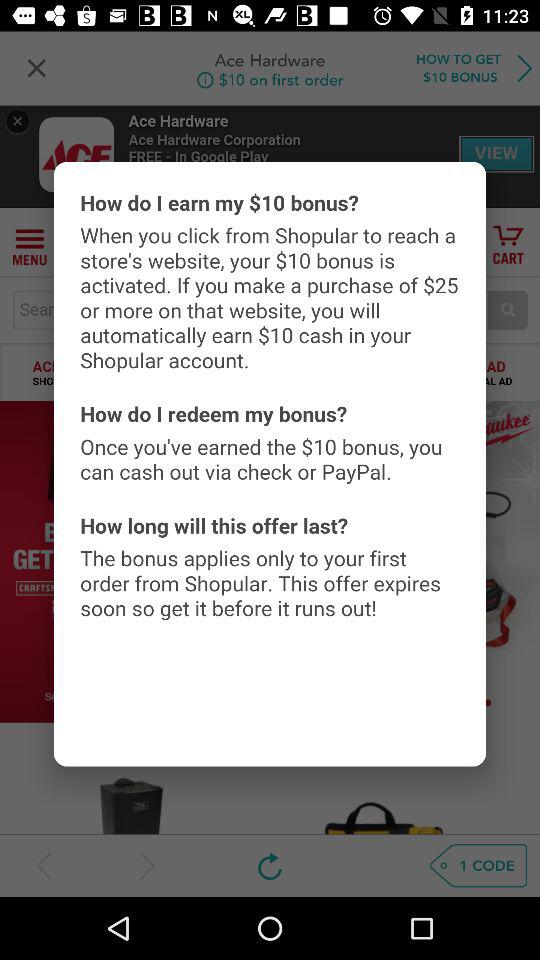What is the minimum amount I need to spend to earn the $10 bonus?
Answer the question using a single word or phrase. $25 